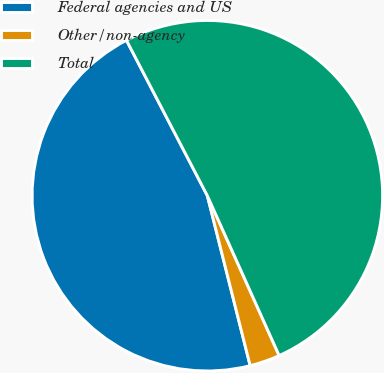Convert chart to OTSL. <chart><loc_0><loc_0><loc_500><loc_500><pie_chart><fcel>Federal agencies and US<fcel>Other/non-agency<fcel>Total<nl><fcel>46.29%<fcel>2.79%<fcel>50.92%<nl></chart> 